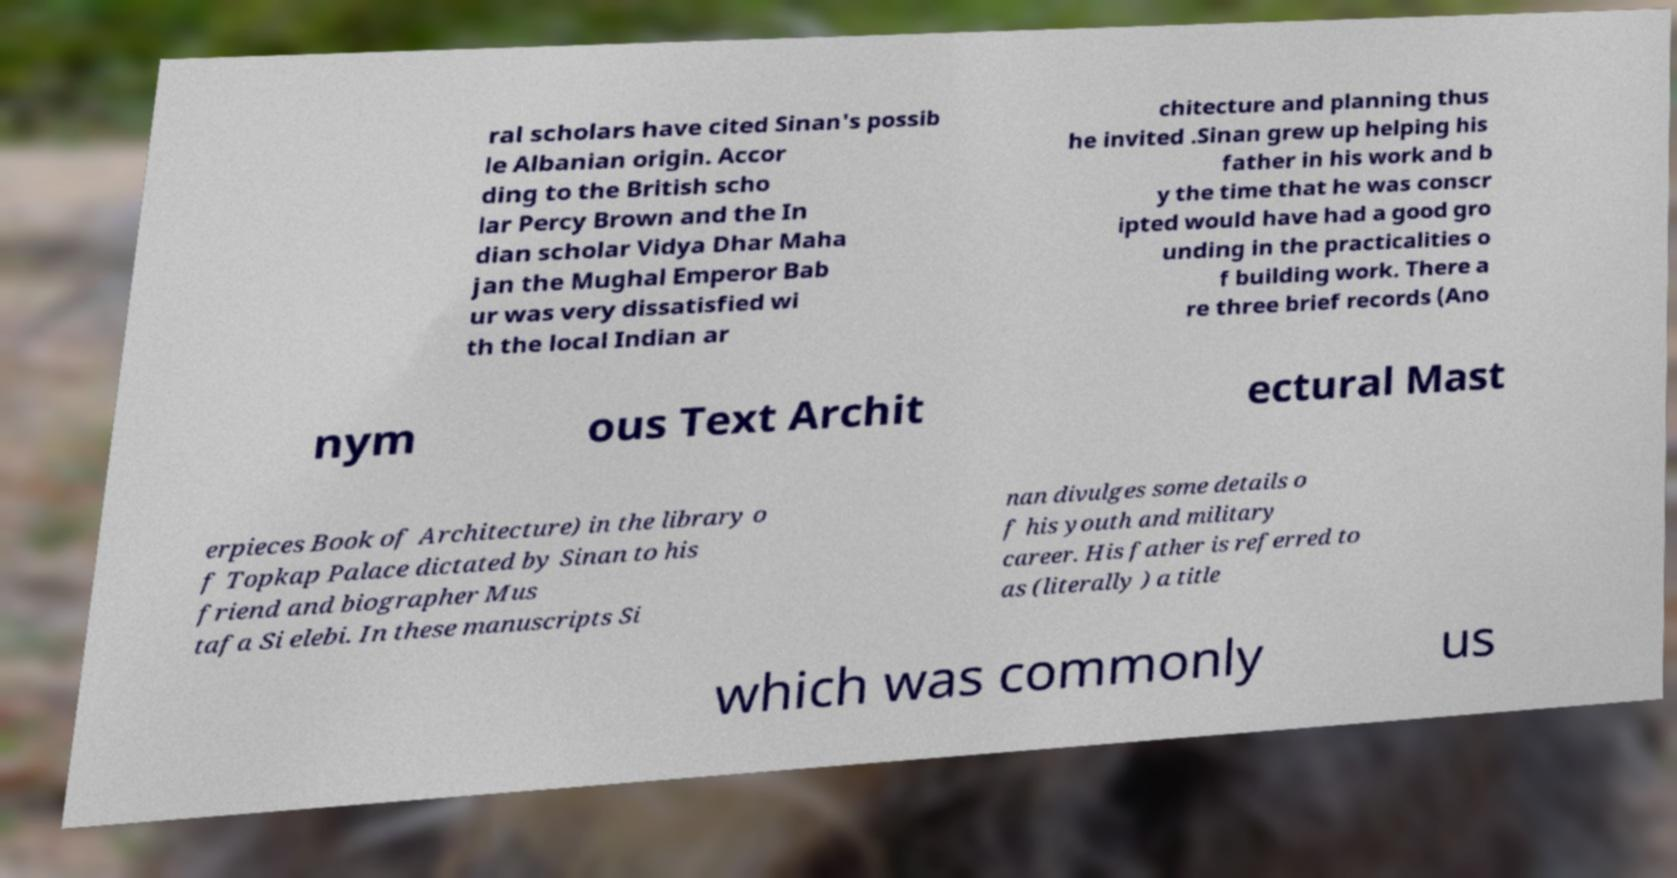What messages or text are displayed in this image? I need them in a readable, typed format. ral scholars have cited Sinan's possib le Albanian origin. Accor ding to the British scho lar Percy Brown and the In dian scholar Vidya Dhar Maha jan the Mughal Emperor Bab ur was very dissatisfied wi th the local Indian ar chitecture and planning thus he invited .Sinan grew up helping his father in his work and b y the time that he was conscr ipted would have had a good gro unding in the practicalities o f building work. There a re three brief records (Ano nym ous Text Archit ectural Mast erpieces Book of Architecture) in the library o f Topkap Palace dictated by Sinan to his friend and biographer Mus tafa Si elebi. In these manuscripts Si nan divulges some details o f his youth and military career. His father is referred to as (literally ) a title which was commonly us 